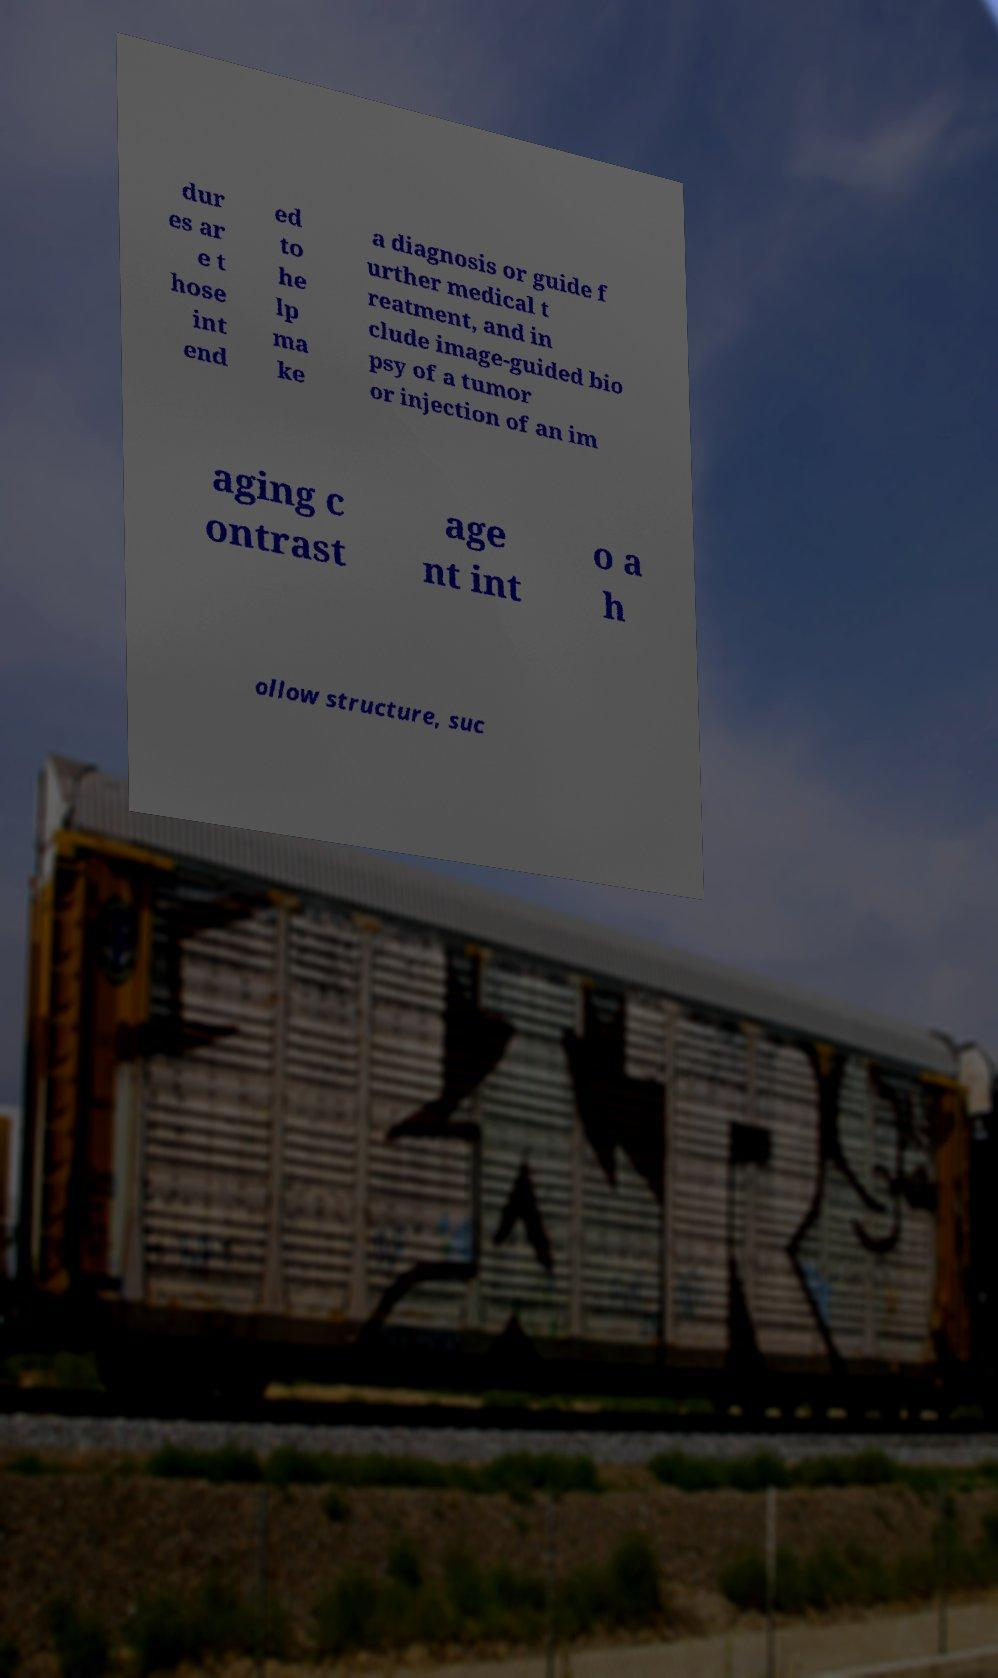I need the written content from this picture converted into text. Can you do that? dur es ar e t hose int end ed to he lp ma ke a diagnosis or guide f urther medical t reatment, and in clude image-guided bio psy of a tumor or injection of an im aging c ontrast age nt int o a h ollow structure, suc 